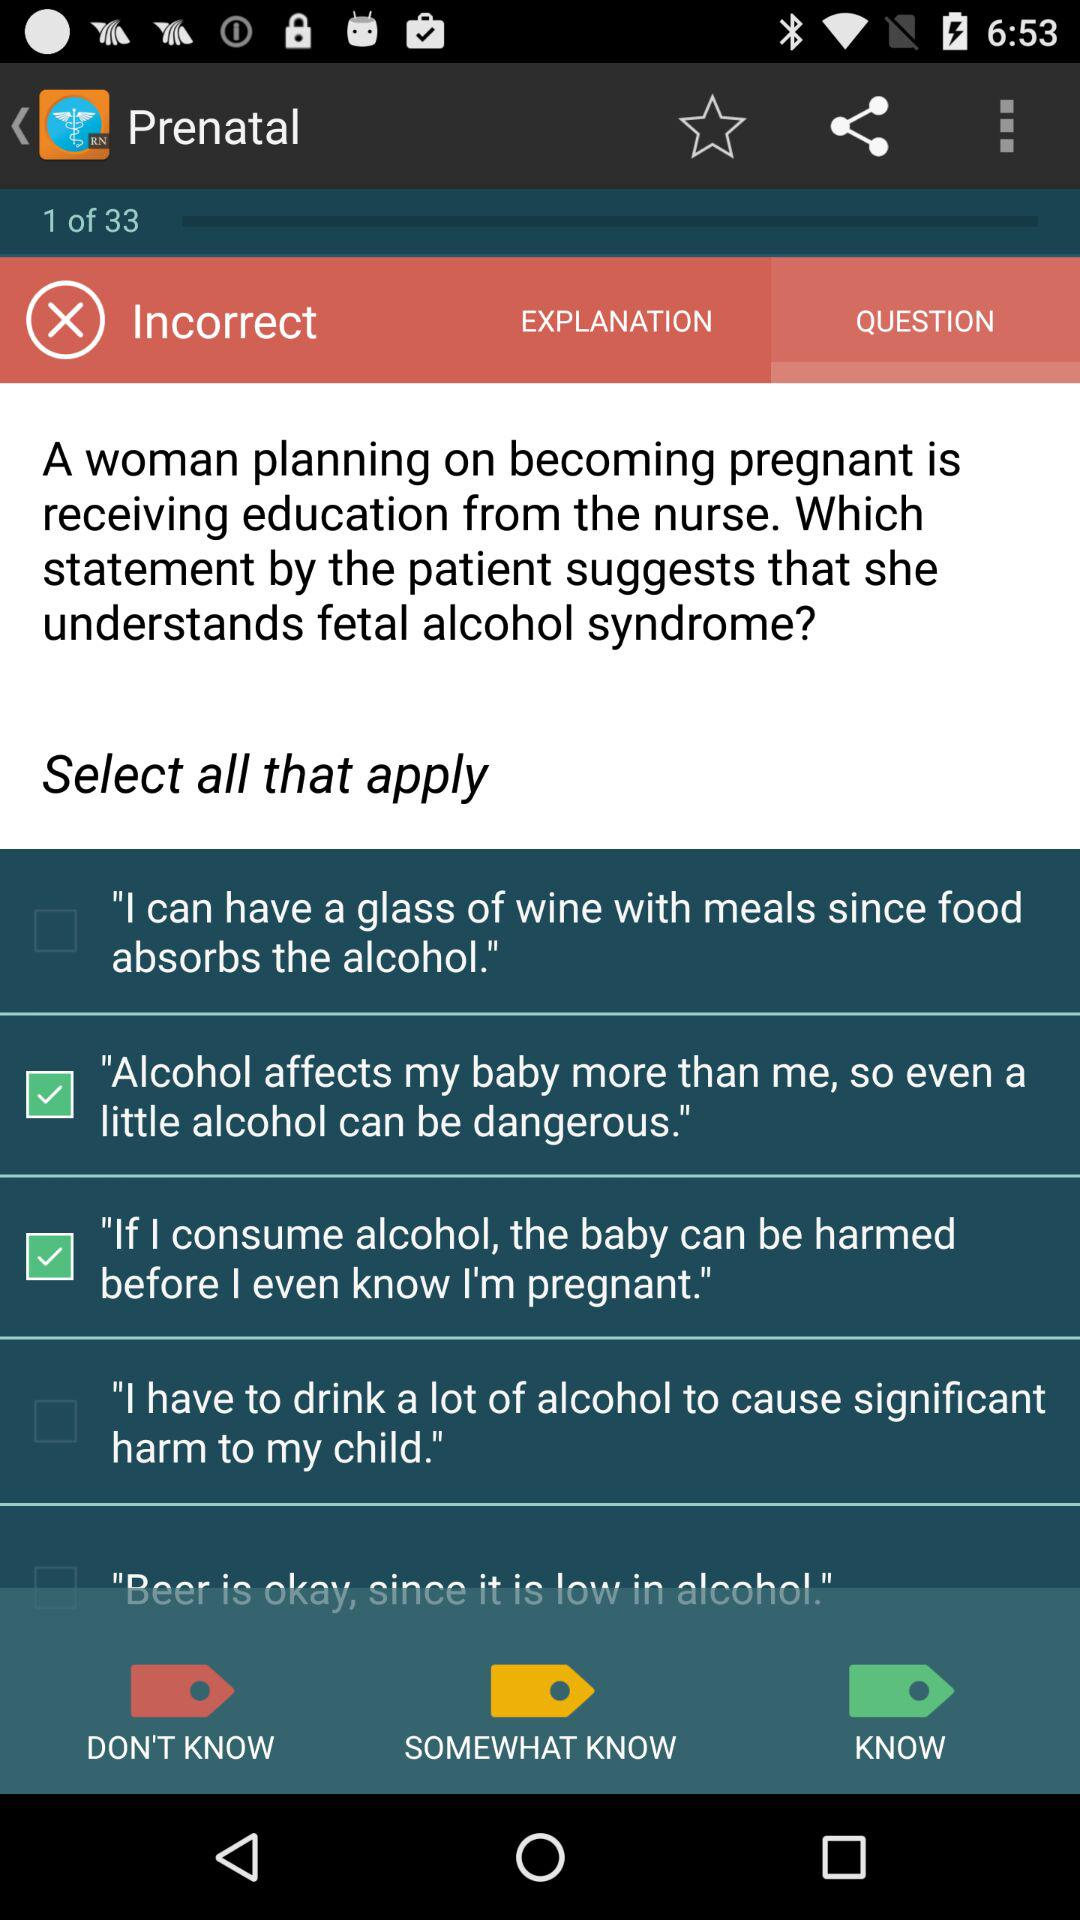How many total questions are there? There are 33 questions. 